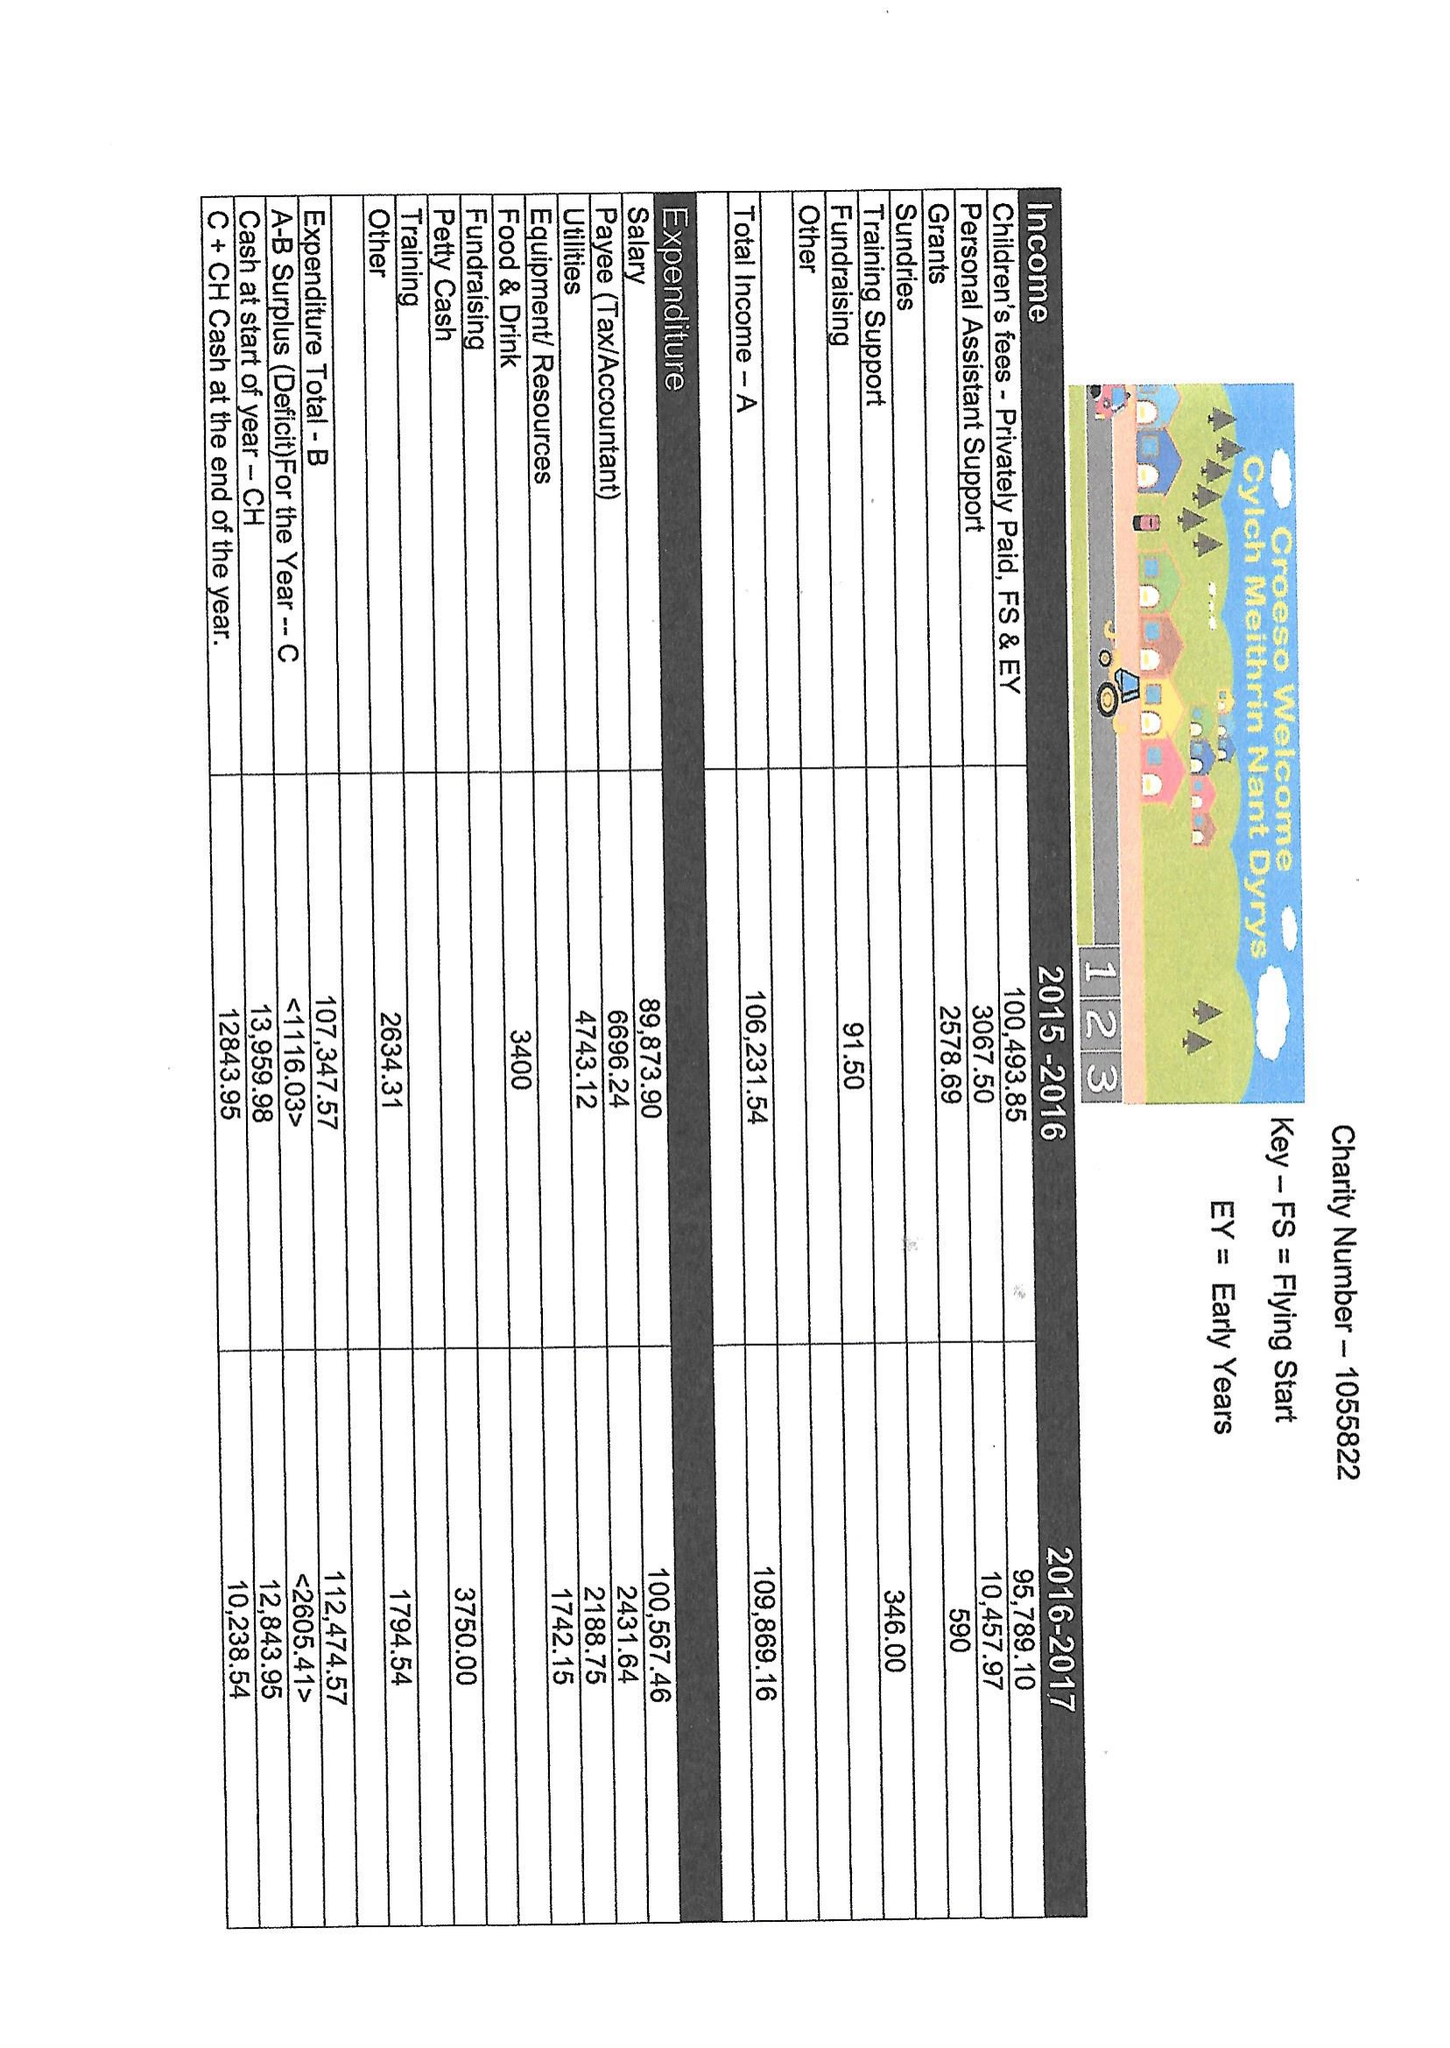What is the value for the charity_name?
Answer the question using a single word or phrase. Cylch Meithrin Nant Dyrys 